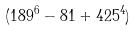Convert formula to latex. <formula><loc_0><loc_0><loc_500><loc_500>( 1 8 9 ^ { 6 } - 8 1 + 4 2 5 ^ { 4 } )</formula> 